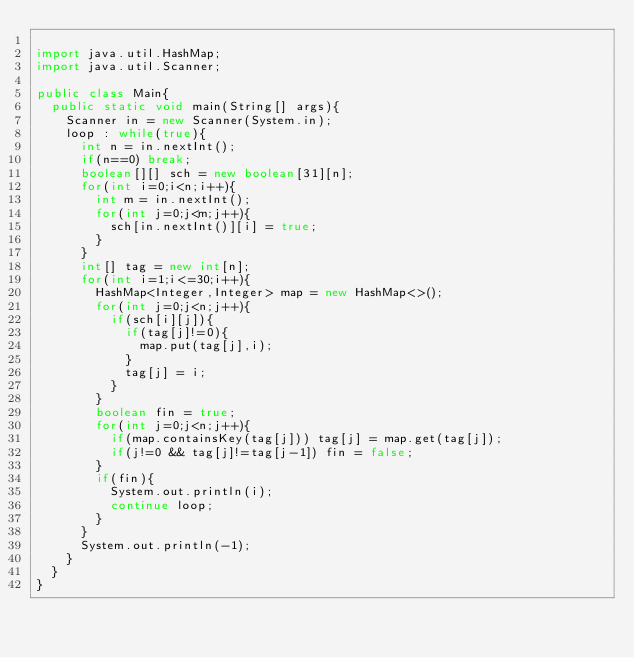<code> <loc_0><loc_0><loc_500><loc_500><_Java_>
import java.util.HashMap;
import java.util.Scanner;

public class Main{
	public static void main(String[] args){
		Scanner in = new Scanner(System.in);
		loop : while(true){
			int n = in.nextInt();
			if(n==0) break;
			boolean[][] sch = new boolean[31][n];
			for(int i=0;i<n;i++){
				int m = in.nextInt();
				for(int j=0;j<m;j++){
					sch[in.nextInt()][i] = true;
				}
			}
			int[] tag = new int[n];
			for(int i=1;i<=30;i++){
				HashMap<Integer,Integer> map = new HashMap<>();
				for(int j=0;j<n;j++){
					if(sch[i][j]){
						if(tag[j]!=0){
							map.put(tag[j],i);
						}
						tag[j] = i;
					}
				}
				boolean fin = true;
				for(int j=0;j<n;j++){
					if(map.containsKey(tag[j])) tag[j] = map.get(tag[j]);
					if(j!=0 && tag[j]!=tag[j-1]) fin = false;
				}
				if(fin){
					System.out.println(i);
					continue loop;
				}
			}
			System.out.println(-1);
		}
	}
}</code> 